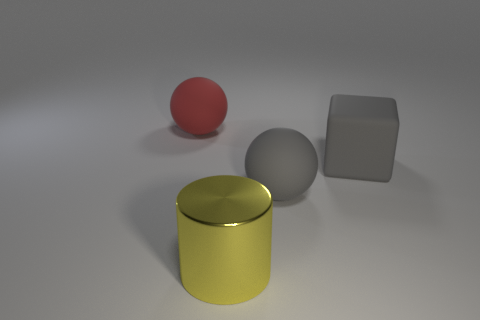Add 4 big yellow cylinders. How many objects exist? 8 Subtract all cubes. How many objects are left? 3 Subtract all large green metallic things. Subtract all large metal cylinders. How many objects are left? 3 Add 4 big blocks. How many big blocks are left? 5 Add 3 large purple cylinders. How many large purple cylinders exist? 3 Subtract 0 blue cubes. How many objects are left? 4 